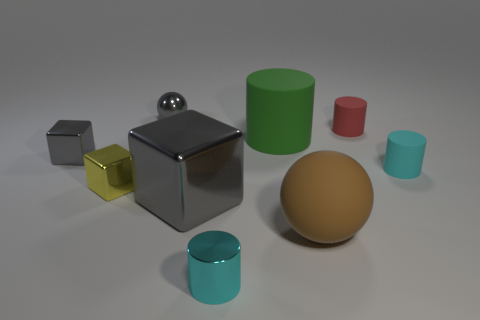Add 1 gray cubes. How many objects exist? 10 Subtract all balls. How many objects are left? 7 Subtract all red cylinders. Subtract all tiny yellow objects. How many objects are left? 7 Add 3 large gray shiny things. How many large gray shiny things are left? 4 Add 4 small gray metallic blocks. How many small gray metallic blocks exist? 5 Subtract 0 blue cylinders. How many objects are left? 9 